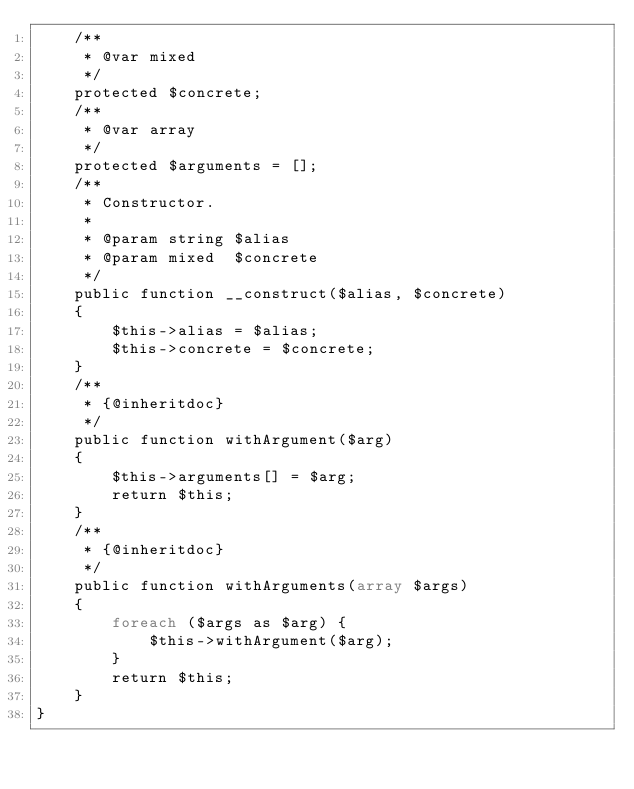Convert code to text. <code><loc_0><loc_0><loc_500><loc_500><_PHP_>    /**
     * @var mixed
     */
    protected $concrete;
    /**
     * @var array
     */
    protected $arguments = [];
    /**
     * Constructor.
     *
     * @param string $alias
     * @param mixed  $concrete
     */
    public function __construct($alias, $concrete)
    {
        $this->alias = $alias;
        $this->concrete = $concrete;
    }
    /**
     * {@inheritdoc}
     */
    public function withArgument($arg)
    {
        $this->arguments[] = $arg;
        return $this;
    }
    /**
     * {@inheritdoc}
     */
    public function withArguments(array $args)
    {
        foreach ($args as $arg) {
            $this->withArgument($arg);
        }
        return $this;
    }
}
</code> 